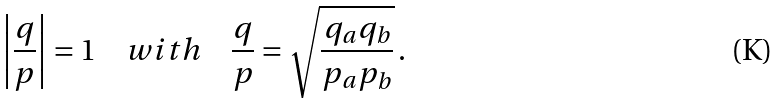Convert formula to latex. <formula><loc_0><loc_0><loc_500><loc_500>\left | \frac { q } { p } \right | = 1 \quad w i t h \quad \frac { q } { p } = \sqrt { \frac { q _ { a } q _ { b } } { p _ { a } p _ { b } } } \, .</formula> 